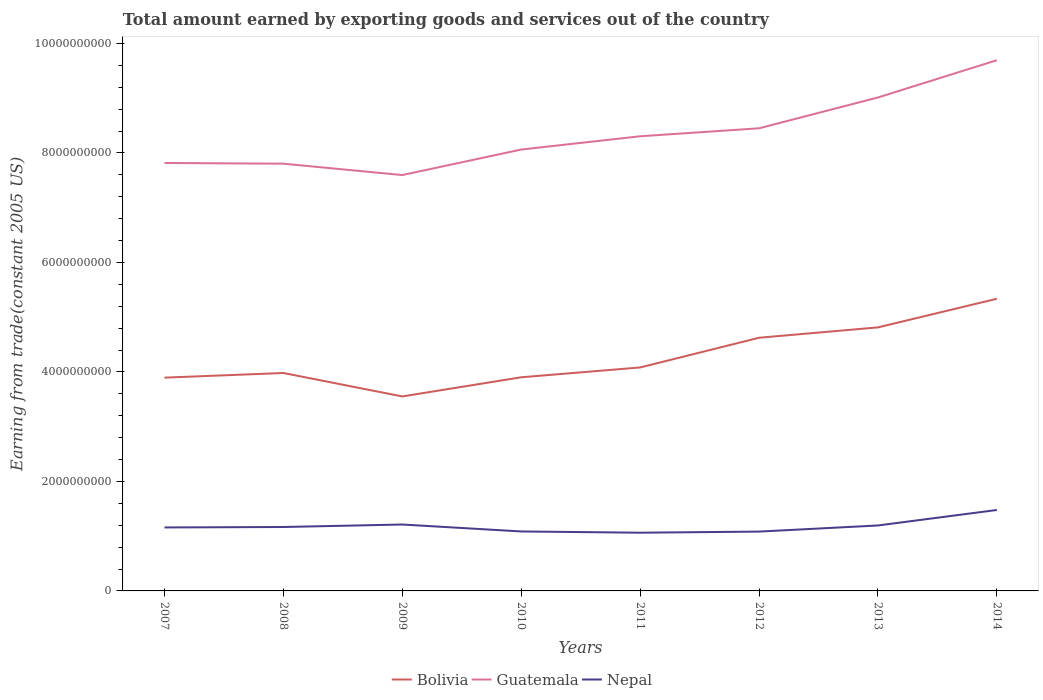How many different coloured lines are there?
Your answer should be very brief. 3. Is the number of lines equal to the number of legend labels?
Offer a very short reply. Yes. Across all years, what is the maximum total amount earned by exporting goods and services in Nepal?
Your answer should be compact. 1.06e+09. What is the total total amount earned by exporting goods and services in Bolivia in the graph?
Your answer should be very brief. -1.44e+09. What is the difference between the highest and the second highest total amount earned by exporting goods and services in Nepal?
Offer a terse response. 4.15e+08. What is the difference between the highest and the lowest total amount earned by exporting goods and services in Bolivia?
Offer a terse response. 3. Is the total amount earned by exporting goods and services in Nepal strictly greater than the total amount earned by exporting goods and services in Guatemala over the years?
Offer a terse response. Yes. Where does the legend appear in the graph?
Offer a terse response. Bottom center. How many legend labels are there?
Offer a terse response. 3. What is the title of the graph?
Make the answer very short. Total amount earned by exporting goods and services out of the country. What is the label or title of the Y-axis?
Give a very brief answer. Earning from trade(constant 2005 US). What is the Earning from trade(constant 2005 US) of Bolivia in 2007?
Your answer should be very brief. 3.90e+09. What is the Earning from trade(constant 2005 US) in Guatemala in 2007?
Give a very brief answer. 7.82e+09. What is the Earning from trade(constant 2005 US) of Nepal in 2007?
Your answer should be very brief. 1.16e+09. What is the Earning from trade(constant 2005 US) of Bolivia in 2008?
Offer a very short reply. 3.98e+09. What is the Earning from trade(constant 2005 US) of Guatemala in 2008?
Your response must be concise. 7.80e+09. What is the Earning from trade(constant 2005 US) in Nepal in 2008?
Offer a terse response. 1.17e+09. What is the Earning from trade(constant 2005 US) of Bolivia in 2009?
Provide a short and direct response. 3.55e+09. What is the Earning from trade(constant 2005 US) in Guatemala in 2009?
Your answer should be very brief. 7.60e+09. What is the Earning from trade(constant 2005 US) in Nepal in 2009?
Make the answer very short. 1.21e+09. What is the Earning from trade(constant 2005 US) in Bolivia in 2010?
Give a very brief answer. 3.90e+09. What is the Earning from trade(constant 2005 US) in Guatemala in 2010?
Ensure brevity in your answer.  8.06e+09. What is the Earning from trade(constant 2005 US) in Nepal in 2010?
Your answer should be compact. 1.09e+09. What is the Earning from trade(constant 2005 US) in Bolivia in 2011?
Provide a succinct answer. 4.08e+09. What is the Earning from trade(constant 2005 US) in Guatemala in 2011?
Make the answer very short. 8.31e+09. What is the Earning from trade(constant 2005 US) in Nepal in 2011?
Your answer should be very brief. 1.06e+09. What is the Earning from trade(constant 2005 US) in Bolivia in 2012?
Your answer should be very brief. 4.62e+09. What is the Earning from trade(constant 2005 US) in Guatemala in 2012?
Provide a short and direct response. 8.45e+09. What is the Earning from trade(constant 2005 US) in Nepal in 2012?
Give a very brief answer. 1.08e+09. What is the Earning from trade(constant 2005 US) in Bolivia in 2013?
Offer a very short reply. 4.81e+09. What is the Earning from trade(constant 2005 US) of Guatemala in 2013?
Ensure brevity in your answer.  9.01e+09. What is the Earning from trade(constant 2005 US) in Nepal in 2013?
Your response must be concise. 1.20e+09. What is the Earning from trade(constant 2005 US) in Bolivia in 2014?
Your answer should be very brief. 5.34e+09. What is the Earning from trade(constant 2005 US) in Guatemala in 2014?
Keep it short and to the point. 9.69e+09. What is the Earning from trade(constant 2005 US) of Nepal in 2014?
Your response must be concise. 1.48e+09. Across all years, what is the maximum Earning from trade(constant 2005 US) in Bolivia?
Ensure brevity in your answer.  5.34e+09. Across all years, what is the maximum Earning from trade(constant 2005 US) of Guatemala?
Your answer should be very brief. 9.69e+09. Across all years, what is the maximum Earning from trade(constant 2005 US) of Nepal?
Keep it short and to the point. 1.48e+09. Across all years, what is the minimum Earning from trade(constant 2005 US) in Bolivia?
Keep it short and to the point. 3.55e+09. Across all years, what is the minimum Earning from trade(constant 2005 US) of Guatemala?
Your response must be concise. 7.60e+09. Across all years, what is the minimum Earning from trade(constant 2005 US) of Nepal?
Your response must be concise. 1.06e+09. What is the total Earning from trade(constant 2005 US) of Bolivia in the graph?
Provide a succinct answer. 3.42e+1. What is the total Earning from trade(constant 2005 US) in Guatemala in the graph?
Make the answer very short. 6.67e+1. What is the total Earning from trade(constant 2005 US) of Nepal in the graph?
Make the answer very short. 9.45e+09. What is the difference between the Earning from trade(constant 2005 US) in Bolivia in 2007 and that in 2008?
Offer a terse response. -8.47e+07. What is the difference between the Earning from trade(constant 2005 US) in Guatemala in 2007 and that in 2008?
Your answer should be compact. 1.27e+07. What is the difference between the Earning from trade(constant 2005 US) in Nepal in 2007 and that in 2008?
Give a very brief answer. -8.43e+06. What is the difference between the Earning from trade(constant 2005 US) of Bolivia in 2007 and that in 2009?
Keep it short and to the point. 3.43e+08. What is the difference between the Earning from trade(constant 2005 US) of Guatemala in 2007 and that in 2009?
Offer a terse response. 2.20e+08. What is the difference between the Earning from trade(constant 2005 US) in Nepal in 2007 and that in 2009?
Ensure brevity in your answer.  -5.36e+07. What is the difference between the Earning from trade(constant 2005 US) of Bolivia in 2007 and that in 2010?
Offer a terse response. -6.59e+06. What is the difference between the Earning from trade(constant 2005 US) of Guatemala in 2007 and that in 2010?
Offer a very short reply. -2.46e+08. What is the difference between the Earning from trade(constant 2005 US) of Nepal in 2007 and that in 2010?
Give a very brief answer. 7.30e+07. What is the difference between the Earning from trade(constant 2005 US) in Bolivia in 2007 and that in 2011?
Offer a terse response. -1.86e+08. What is the difference between the Earning from trade(constant 2005 US) in Guatemala in 2007 and that in 2011?
Keep it short and to the point. -4.88e+08. What is the difference between the Earning from trade(constant 2005 US) of Nepal in 2007 and that in 2011?
Provide a short and direct response. 9.59e+07. What is the difference between the Earning from trade(constant 2005 US) of Bolivia in 2007 and that in 2012?
Your answer should be very brief. -7.29e+08. What is the difference between the Earning from trade(constant 2005 US) in Guatemala in 2007 and that in 2012?
Provide a succinct answer. -6.34e+08. What is the difference between the Earning from trade(constant 2005 US) of Nepal in 2007 and that in 2012?
Your answer should be compact. 7.56e+07. What is the difference between the Earning from trade(constant 2005 US) in Bolivia in 2007 and that in 2013?
Make the answer very short. -9.18e+08. What is the difference between the Earning from trade(constant 2005 US) of Guatemala in 2007 and that in 2013?
Your answer should be compact. -1.20e+09. What is the difference between the Earning from trade(constant 2005 US) in Nepal in 2007 and that in 2013?
Keep it short and to the point. -3.64e+07. What is the difference between the Earning from trade(constant 2005 US) of Bolivia in 2007 and that in 2014?
Offer a very short reply. -1.44e+09. What is the difference between the Earning from trade(constant 2005 US) in Guatemala in 2007 and that in 2014?
Provide a succinct answer. -1.88e+09. What is the difference between the Earning from trade(constant 2005 US) of Nepal in 2007 and that in 2014?
Your response must be concise. -3.19e+08. What is the difference between the Earning from trade(constant 2005 US) in Bolivia in 2008 and that in 2009?
Your response must be concise. 4.28e+08. What is the difference between the Earning from trade(constant 2005 US) in Guatemala in 2008 and that in 2009?
Offer a very short reply. 2.08e+08. What is the difference between the Earning from trade(constant 2005 US) in Nepal in 2008 and that in 2009?
Offer a very short reply. -4.52e+07. What is the difference between the Earning from trade(constant 2005 US) of Bolivia in 2008 and that in 2010?
Ensure brevity in your answer.  7.81e+07. What is the difference between the Earning from trade(constant 2005 US) of Guatemala in 2008 and that in 2010?
Provide a succinct answer. -2.58e+08. What is the difference between the Earning from trade(constant 2005 US) of Nepal in 2008 and that in 2010?
Offer a very short reply. 8.14e+07. What is the difference between the Earning from trade(constant 2005 US) of Bolivia in 2008 and that in 2011?
Your response must be concise. -1.01e+08. What is the difference between the Earning from trade(constant 2005 US) of Guatemala in 2008 and that in 2011?
Make the answer very short. -5.01e+08. What is the difference between the Earning from trade(constant 2005 US) in Nepal in 2008 and that in 2011?
Your answer should be compact. 1.04e+08. What is the difference between the Earning from trade(constant 2005 US) of Bolivia in 2008 and that in 2012?
Ensure brevity in your answer.  -6.44e+08. What is the difference between the Earning from trade(constant 2005 US) in Guatemala in 2008 and that in 2012?
Your response must be concise. -6.46e+08. What is the difference between the Earning from trade(constant 2005 US) of Nepal in 2008 and that in 2012?
Provide a succinct answer. 8.40e+07. What is the difference between the Earning from trade(constant 2005 US) of Bolivia in 2008 and that in 2013?
Ensure brevity in your answer.  -8.33e+08. What is the difference between the Earning from trade(constant 2005 US) of Guatemala in 2008 and that in 2013?
Ensure brevity in your answer.  -1.21e+09. What is the difference between the Earning from trade(constant 2005 US) of Nepal in 2008 and that in 2013?
Provide a short and direct response. -2.80e+07. What is the difference between the Earning from trade(constant 2005 US) of Bolivia in 2008 and that in 2014?
Provide a short and direct response. -1.36e+09. What is the difference between the Earning from trade(constant 2005 US) in Guatemala in 2008 and that in 2014?
Give a very brief answer. -1.89e+09. What is the difference between the Earning from trade(constant 2005 US) in Nepal in 2008 and that in 2014?
Your answer should be very brief. -3.11e+08. What is the difference between the Earning from trade(constant 2005 US) in Bolivia in 2009 and that in 2010?
Keep it short and to the point. -3.50e+08. What is the difference between the Earning from trade(constant 2005 US) in Guatemala in 2009 and that in 2010?
Your response must be concise. -4.66e+08. What is the difference between the Earning from trade(constant 2005 US) in Nepal in 2009 and that in 2010?
Provide a short and direct response. 1.27e+08. What is the difference between the Earning from trade(constant 2005 US) in Bolivia in 2009 and that in 2011?
Ensure brevity in your answer.  -5.29e+08. What is the difference between the Earning from trade(constant 2005 US) in Guatemala in 2009 and that in 2011?
Your response must be concise. -7.08e+08. What is the difference between the Earning from trade(constant 2005 US) in Nepal in 2009 and that in 2011?
Your answer should be compact. 1.50e+08. What is the difference between the Earning from trade(constant 2005 US) in Bolivia in 2009 and that in 2012?
Make the answer very short. -1.07e+09. What is the difference between the Earning from trade(constant 2005 US) of Guatemala in 2009 and that in 2012?
Your response must be concise. -8.54e+08. What is the difference between the Earning from trade(constant 2005 US) in Nepal in 2009 and that in 2012?
Make the answer very short. 1.29e+08. What is the difference between the Earning from trade(constant 2005 US) of Bolivia in 2009 and that in 2013?
Keep it short and to the point. -1.26e+09. What is the difference between the Earning from trade(constant 2005 US) of Guatemala in 2009 and that in 2013?
Your answer should be very brief. -1.42e+09. What is the difference between the Earning from trade(constant 2005 US) in Nepal in 2009 and that in 2013?
Provide a short and direct response. 1.72e+07. What is the difference between the Earning from trade(constant 2005 US) in Bolivia in 2009 and that in 2014?
Your answer should be very brief. -1.78e+09. What is the difference between the Earning from trade(constant 2005 US) of Guatemala in 2009 and that in 2014?
Your answer should be very brief. -2.10e+09. What is the difference between the Earning from trade(constant 2005 US) of Nepal in 2009 and that in 2014?
Your response must be concise. -2.66e+08. What is the difference between the Earning from trade(constant 2005 US) of Bolivia in 2010 and that in 2011?
Your response must be concise. -1.79e+08. What is the difference between the Earning from trade(constant 2005 US) of Guatemala in 2010 and that in 2011?
Make the answer very short. -2.43e+08. What is the difference between the Earning from trade(constant 2005 US) of Nepal in 2010 and that in 2011?
Offer a terse response. 2.30e+07. What is the difference between the Earning from trade(constant 2005 US) of Bolivia in 2010 and that in 2012?
Your response must be concise. -7.22e+08. What is the difference between the Earning from trade(constant 2005 US) of Guatemala in 2010 and that in 2012?
Your answer should be compact. -3.88e+08. What is the difference between the Earning from trade(constant 2005 US) in Nepal in 2010 and that in 2012?
Offer a very short reply. 2.59e+06. What is the difference between the Earning from trade(constant 2005 US) in Bolivia in 2010 and that in 2013?
Ensure brevity in your answer.  -9.11e+08. What is the difference between the Earning from trade(constant 2005 US) in Guatemala in 2010 and that in 2013?
Keep it short and to the point. -9.51e+08. What is the difference between the Earning from trade(constant 2005 US) in Nepal in 2010 and that in 2013?
Offer a terse response. -1.09e+08. What is the difference between the Earning from trade(constant 2005 US) of Bolivia in 2010 and that in 2014?
Ensure brevity in your answer.  -1.43e+09. What is the difference between the Earning from trade(constant 2005 US) in Guatemala in 2010 and that in 2014?
Keep it short and to the point. -1.63e+09. What is the difference between the Earning from trade(constant 2005 US) of Nepal in 2010 and that in 2014?
Your answer should be compact. -3.92e+08. What is the difference between the Earning from trade(constant 2005 US) in Bolivia in 2011 and that in 2012?
Offer a terse response. -5.43e+08. What is the difference between the Earning from trade(constant 2005 US) in Guatemala in 2011 and that in 2012?
Offer a terse response. -1.46e+08. What is the difference between the Earning from trade(constant 2005 US) of Nepal in 2011 and that in 2012?
Your response must be concise. -2.04e+07. What is the difference between the Earning from trade(constant 2005 US) in Bolivia in 2011 and that in 2013?
Your answer should be compact. -7.32e+08. What is the difference between the Earning from trade(constant 2005 US) in Guatemala in 2011 and that in 2013?
Provide a succinct answer. -7.09e+08. What is the difference between the Earning from trade(constant 2005 US) in Nepal in 2011 and that in 2013?
Ensure brevity in your answer.  -1.32e+08. What is the difference between the Earning from trade(constant 2005 US) of Bolivia in 2011 and that in 2014?
Give a very brief answer. -1.26e+09. What is the difference between the Earning from trade(constant 2005 US) in Guatemala in 2011 and that in 2014?
Provide a short and direct response. -1.39e+09. What is the difference between the Earning from trade(constant 2005 US) of Nepal in 2011 and that in 2014?
Provide a short and direct response. -4.15e+08. What is the difference between the Earning from trade(constant 2005 US) of Bolivia in 2012 and that in 2013?
Make the answer very short. -1.89e+08. What is the difference between the Earning from trade(constant 2005 US) in Guatemala in 2012 and that in 2013?
Your answer should be compact. -5.63e+08. What is the difference between the Earning from trade(constant 2005 US) of Nepal in 2012 and that in 2013?
Your answer should be very brief. -1.12e+08. What is the difference between the Earning from trade(constant 2005 US) of Bolivia in 2012 and that in 2014?
Ensure brevity in your answer.  -7.12e+08. What is the difference between the Earning from trade(constant 2005 US) in Guatemala in 2012 and that in 2014?
Provide a succinct answer. -1.24e+09. What is the difference between the Earning from trade(constant 2005 US) of Nepal in 2012 and that in 2014?
Your answer should be compact. -3.95e+08. What is the difference between the Earning from trade(constant 2005 US) of Bolivia in 2013 and that in 2014?
Offer a very short reply. -5.23e+08. What is the difference between the Earning from trade(constant 2005 US) of Guatemala in 2013 and that in 2014?
Ensure brevity in your answer.  -6.81e+08. What is the difference between the Earning from trade(constant 2005 US) of Nepal in 2013 and that in 2014?
Provide a short and direct response. -2.83e+08. What is the difference between the Earning from trade(constant 2005 US) in Bolivia in 2007 and the Earning from trade(constant 2005 US) in Guatemala in 2008?
Your answer should be compact. -3.91e+09. What is the difference between the Earning from trade(constant 2005 US) of Bolivia in 2007 and the Earning from trade(constant 2005 US) of Nepal in 2008?
Your answer should be very brief. 2.73e+09. What is the difference between the Earning from trade(constant 2005 US) in Guatemala in 2007 and the Earning from trade(constant 2005 US) in Nepal in 2008?
Provide a succinct answer. 6.65e+09. What is the difference between the Earning from trade(constant 2005 US) of Bolivia in 2007 and the Earning from trade(constant 2005 US) of Guatemala in 2009?
Your answer should be compact. -3.70e+09. What is the difference between the Earning from trade(constant 2005 US) of Bolivia in 2007 and the Earning from trade(constant 2005 US) of Nepal in 2009?
Keep it short and to the point. 2.68e+09. What is the difference between the Earning from trade(constant 2005 US) in Guatemala in 2007 and the Earning from trade(constant 2005 US) in Nepal in 2009?
Your response must be concise. 6.60e+09. What is the difference between the Earning from trade(constant 2005 US) in Bolivia in 2007 and the Earning from trade(constant 2005 US) in Guatemala in 2010?
Ensure brevity in your answer.  -4.17e+09. What is the difference between the Earning from trade(constant 2005 US) of Bolivia in 2007 and the Earning from trade(constant 2005 US) of Nepal in 2010?
Give a very brief answer. 2.81e+09. What is the difference between the Earning from trade(constant 2005 US) of Guatemala in 2007 and the Earning from trade(constant 2005 US) of Nepal in 2010?
Provide a short and direct response. 6.73e+09. What is the difference between the Earning from trade(constant 2005 US) of Bolivia in 2007 and the Earning from trade(constant 2005 US) of Guatemala in 2011?
Offer a very short reply. -4.41e+09. What is the difference between the Earning from trade(constant 2005 US) in Bolivia in 2007 and the Earning from trade(constant 2005 US) in Nepal in 2011?
Offer a very short reply. 2.83e+09. What is the difference between the Earning from trade(constant 2005 US) of Guatemala in 2007 and the Earning from trade(constant 2005 US) of Nepal in 2011?
Your response must be concise. 6.75e+09. What is the difference between the Earning from trade(constant 2005 US) in Bolivia in 2007 and the Earning from trade(constant 2005 US) in Guatemala in 2012?
Offer a terse response. -4.55e+09. What is the difference between the Earning from trade(constant 2005 US) of Bolivia in 2007 and the Earning from trade(constant 2005 US) of Nepal in 2012?
Ensure brevity in your answer.  2.81e+09. What is the difference between the Earning from trade(constant 2005 US) in Guatemala in 2007 and the Earning from trade(constant 2005 US) in Nepal in 2012?
Give a very brief answer. 6.73e+09. What is the difference between the Earning from trade(constant 2005 US) in Bolivia in 2007 and the Earning from trade(constant 2005 US) in Guatemala in 2013?
Keep it short and to the point. -5.12e+09. What is the difference between the Earning from trade(constant 2005 US) of Bolivia in 2007 and the Earning from trade(constant 2005 US) of Nepal in 2013?
Your answer should be compact. 2.70e+09. What is the difference between the Earning from trade(constant 2005 US) in Guatemala in 2007 and the Earning from trade(constant 2005 US) in Nepal in 2013?
Make the answer very short. 6.62e+09. What is the difference between the Earning from trade(constant 2005 US) in Bolivia in 2007 and the Earning from trade(constant 2005 US) in Guatemala in 2014?
Offer a very short reply. -5.80e+09. What is the difference between the Earning from trade(constant 2005 US) of Bolivia in 2007 and the Earning from trade(constant 2005 US) of Nepal in 2014?
Offer a very short reply. 2.42e+09. What is the difference between the Earning from trade(constant 2005 US) in Guatemala in 2007 and the Earning from trade(constant 2005 US) in Nepal in 2014?
Offer a very short reply. 6.34e+09. What is the difference between the Earning from trade(constant 2005 US) in Bolivia in 2008 and the Earning from trade(constant 2005 US) in Guatemala in 2009?
Offer a very short reply. -3.62e+09. What is the difference between the Earning from trade(constant 2005 US) in Bolivia in 2008 and the Earning from trade(constant 2005 US) in Nepal in 2009?
Keep it short and to the point. 2.77e+09. What is the difference between the Earning from trade(constant 2005 US) in Guatemala in 2008 and the Earning from trade(constant 2005 US) in Nepal in 2009?
Offer a terse response. 6.59e+09. What is the difference between the Earning from trade(constant 2005 US) in Bolivia in 2008 and the Earning from trade(constant 2005 US) in Guatemala in 2010?
Offer a very short reply. -4.08e+09. What is the difference between the Earning from trade(constant 2005 US) of Bolivia in 2008 and the Earning from trade(constant 2005 US) of Nepal in 2010?
Your answer should be very brief. 2.89e+09. What is the difference between the Earning from trade(constant 2005 US) in Guatemala in 2008 and the Earning from trade(constant 2005 US) in Nepal in 2010?
Keep it short and to the point. 6.72e+09. What is the difference between the Earning from trade(constant 2005 US) of Bolivia in 2008 and the Earning from trade(constant 2005 US) of Guatemala in 2011?
Keep it short and to the point. -4.32e+09. What is the difference between the Earning from trade(constant 2005 US) in Bolivia in 2008 and the Earning from trade(constant 2005 US) in Nepal in 2011?
Offer a very short reply. 2.92e+09. What is the difference between the Earning from trade(constant 2005 US) in Guatemala in 2008 and the Earning from trade(constant 2005 US) in Nepal in 2011?
Provide a short and direct response. 6.74e+09. What is the difference between the Earning from trade(constant 2005 US) in Bolivia in 2008 and the Earning from trade(constant 2005 US) in Guatemala in 2012?
Offer a very short reply. -4.47e+09. What is the difference between the Earning from trade(constant 2005 US) of Bolivia in 2008 and the Earning from trade(constant 2005 US) of Nepal in 2012?
Offer a very short reply. 2.90e+09. What is the difference between the Earning from trade(constant 2005 US) in Guatemala in 2008 and the Earning from trade(constant 2005 US) in Nepal in 2012?
Your answer should be compact. 6.72e+09. What is the difference between the Earning from trade(constant 2005 US) of Bolivia in 2008 and the Earning from trade(constant 2005 US) of Guatemala in 2013?
Ensure brevity in your answer.  -5.03e+09. What is the difference between the Earning from trade(constant 2005 US) of Bolivia in 2008 and the Earning from trade(constant 2005 US) of Nepal in 2013?
Offer a very short reply. 2.79e+09. What is the difference between the Earning from trade(constant 2005 US) of Guatemala in 2008 and the Earning from trade(constant 2005 US) of Nepal in 2013?
Your response must be concise. 6.61e+09. What is the difference between the Earning from trade(constant 2005 US) of Bolivia in 2008 and the Earning from trade(constant 2005 US) of Guatemala in 2014?
Offer a very short reply. -5.71e+09. What is the difference between the Earning from trade(constant 2005 US) of Bolivia in 2008 and the Earning from trade(constant 2005 US) of Nepal in 2014?
Your answer should be compact. 2.50e+09. What is the difference between the Earning from trade(constant 2005 US) of Guatemala in 2008 and the Earning from trade(constant 2005 US) of Nepal in 2014?
Provide a short and direct response. 6.33e+09. What is the difference between the Earning from trade(constant 2005 US) of Bolivia in 2009 and the Earning from trade(constant 2005 US) of Guatemala in 2010?
Make the answer very short. -4.51e+09. What is the difference between the Earning from trade(constant 2005 US) of Bolivia in 2009 and the Earning from trade(constant 2005 US) of Nepal in 2010?
Offer a very short reply. 2.47e+09. What is the difference between the Earning from trade(constant 2005 US) in Guatemala in 2009 and the Earning from trade(constant 2005 US) in Nepal in 2010?
Offer a terse response. 6.51e+09. What is the difference between the Earning from trade(constant 2005 US) in Bolivia in 2009 and the Earning from trade(constant 2005 US) in Guatemala in 2011?
Your response must be concise. -4.75e+09. What is the difference between the Earning from trade(constant 2005 US) of Bolivia in 2009 and the Earning from trade(constant 2005 US) of Nepal in 2011?
Ensure brevity in your answer.  2.49e+09. What is the difference between the Earning from trade(constant 2005 US) of Guatemala in 2009 and the Earning from trade(constant 2005 US) of Nepal in 2011?
Offer a very short reply. 6.53e+09. What is the difference between the Earning from trade(constant 2005 US) of Bolivia in 2009 and the Earning from trade(constant 2005 US) of Guatemala in 2012?
Your answer should be very brief. -4.90e+09. What is the difference between the Earning from trade(constant 2005 US) in Bolivia in 2009 and the Earning from trade(constant 2005 US) in Nepal in 2012?
Your answer should be very brief. 2.47e+09. What is the difference between the Earning from trade(constant 2005 US) in Guatemala in 2009 and the Earning from trade(constant 2005 US) in Nepal in 2012?
Make the answer very short. 6.51e+09. What is the difference between the Earning from trade(constant 2005 US) in Bolivia in 2009 and the Earning from trade(constant 2005 US) in Guatemala in 2013?
Your answer should be compact. -5.46e+09. What is the difference between the Earning from trade(constant 2005 US) of Bolivia in 2009 and the Earning from trade(constant 2005 US) of Nepal in 2013?
Provide a succinct answer. 2.36e+09. What is the difference between the Earning from trade(constant 2005 US) of Guatemala in 2009 and the Earning from trade(constant 2005 US) of Nepal in 2013?
Ensure brevity in your answer.  6.40e+09. What is the difference between the Earning from trade(constant 2005 US) in Bolivia in 2009 and the Earning from trade(constant 2005 US) in Guatemala in 2014?
Keep it short and to the point. -6.14e+09. What is the difference between the Earning from trade(constant 2005 US) in Bolivia in 2009 and the Earning from trade(constant 2005 US) in Nepal in 2014?
Your response must be concise. 2.07e+09. What is the difference between the Earning from trade(constant 2005 US) of Guatemala in 2009 and the Earning from trade(constant 2005 US) of Nepal in 2014?
Offer a terse response. 6.12e+09. What is the difference between the Earning from trade(constant 2005 US) in Bolivia in 2010 and the Earning from trade(constant 2005 US) in Guatemala in 2011?
Your answer should be very brief. -4.40e+09. What is the difference between the Earning from trade(constant 2005 US) in Bolivia in 2010 and the Earning from trade(constant 2005 US) in Nepal in 2011?
Offer a terse response. 2.84e+09. What is the difference between the Earning from trade(constant 2005 US) of Guatemala in 2010 and the Earning from trade(constant 2005 US) of Nepal in 2011?
Keep it short and to the point. 7.00e+09. What is the difference between the Earning from trade(constant 2005 US) in Bolivia in 2010 and the Earning from trade(constant 2005 US) in Guatemala in 2012?
Offer a terse response. -4.55e+09. What is the difference between the Earning from trade(constant 2005 US) in Bolivia in 2010 and the Earning from trade(constant 2005 US) in Nepal in 2012?
Your answer should be compact. 2.82e+09. What is the difference between the Earning from trade(constant 2005 US) in Guatemala in 2010 and the Earning from trade(constant 2005 US) in Nepal in 2012?
Give a very brief answer. 6.98e+09. What is the difference between the Earning from trade(constant 2005 US) in Bolivia in 2010 and the Earning from trade(constant 2005 US) in Guatemala in 2013?
Ensure brevity in your answer.  -5.11e+09. What is the difference between the Earning from trade(constant 2005 US) of Bolivia in 2010 and the Earning from trade(constant 2005 US) of Nepal in 2013?
Offer a terse response. 2.71e+09. What is the difference between the Earning from trade(constant 2005 US) of Guatemala in 2010 and the Earning from trade(constant 2005 US) of Nepal in 2013?
Offer a terse response. 6.87e+09. What is the difference between the Earning from trade(constant 2005 US) of Bolivia in 2010 and the Earning from trade(constant 2005 US) of Guatemala in 2014?
Your response must be concise. -5.79e+09. What is the difference between the Earning from trade(constant 2005 US) of Bolivia in 2010 and the Earning from trade(constant 2005 US) of Nepal in 2014?
Provide a short and direct response. 2.42e+09. What is the difference between the Earning from trade(constant 2005 US) of Guatemala in 2010 and the Earning from trade(constant 2005 US) of Nepal in 2014?
Offer a terse response. 6.58e+09. What is the difference between the Earning from trade(constant 2005 US) of Bolivia in 2011 and the Earning from trade(constant 2005 US) of Guatemala in 2012?
Your answer should be compact. -4.37e+09. What is the difference between the Earning from trade(constant 2005 US) of Bolivia in 2011 and the Earning from trade(constant 2005 US) of Nepal in 2012?
Your answer should be compact. 3.00e+09. What is the difference between the Earning from trade(constant 2005 US) of Guatemala in 2011 and the Earning from trade(constant 2005 US) of Nepal in 2012?
Your answer should be very brief. 7.22e+09. What is the difference between the Earning from trade(constant 2005 US) in Bolivia in 2011 and the Earning from trade(constant 2005 US) in Guatemala in 2013?
Keep it short and to the point. -4.93e+09. What is the difference between the Earning from trade(constant 2005 US) in Bolivia in 2011 and the Earning from trade(constant 2005 US) in Nepal in 2013?
Your answer should be very brief. 2.89e+09. What is the difference between the Earning from trade(constant 2005 US) of Guatemala in 2011 and the Earning from trade(constant 2005 US) of Nepal in 2013?
Give a very brief answer. 7.11e+09. What is the difference between the Earning from trade(constant 2005 US) in Bolivia in 2011 and the Earning from trade(constant 2005 US) in Guatemala in 2014?
Offer a very short reply. -5.61e+09. What is the difference between the Earning from trade(constant 2005 US) in Bolivia in 2011 and the Earning from trade(constant 2005 US) in Nepal in 2014?
Give a very brief answer. 2.60e+09. What is the difference between the Earning from trade(constant 2005 US) of Guatemala in 2011 and the Earning from trade(constant 2005 US) of Nepal in 2014?
Your response must be concise. 6.83e+09. What is the difference between the Earning from trade(constant 2005 US) of Bolivia in 2012 and the Earning from trade(constant 2005 US) of Guatemala in 2013?
Offer a terse response. -4.39e+09. What is the difference between the Earning from trade(constant 2005 US) of Bolivia in 2012 and the Earning from trade(constant 2005 US) of Nepal in 2013?
Provide a succinct answer. 3.43e+09. What is the difference between the Earning from trade(constant 2005 US) in Guatemala in 2012 and the Earning from trade(constant 2005 US) in Nepal in 2013?
Your answer should be compact. 7.26e+09. What is the difference between the Earning from trade(constant 2005 US) in Bolivia in 2012 and the Earning from trade(constant 2005 US) in Guatemala in 2014?
Keep it short and to the point. -5.07e+09. What is the difference between the Earning from trade(constant 2005 US) in Bolivia in 2012 and the Earning from trade(constant 2005 US) in Nepal in 2014?
Provide a succinct answer. 3.15e+09. What is the difference between the Earning from trade(constant 2005 US) in Guatemala in 2012 and the Earning from trade(constant 2005 US) in Nepal in 2014?
Your response must be concise. 6.97e+09. What is the difference between the Earning from trade(constant 2005 US) in Bolivia in 2013 and the Earning from trade(constant 2005 US) in Guatemala in 2014?
Ensure brevity in your answer.  -4.88e+09. What is the difference between the Earning from trade(constant 2005 US) of Bolivia in 2013 and the Earning from trade(constant 2005 US) of Nepal in 2014?
Make the answer very short. 3.34e+09. What is the difference between the Earning from trade(constant 2005 US) in Guatemala in 2013 and the Earning from trade(constant 2005 US) in Nepal in 2014?
Provide a succinct answer. 7.54e+09. What is the average Earning from trade(constant 2005 US) in Bolivia per year?
Ensure brevity in your answer.  4.27e+09. What is the average Earning from trade(constant 2005 US) of Guatemala per year?
Your response must be concise. 8.34e+09. What is the average Earning from trade(constant 2005 US) of Nepal per year?
Your answer should be very brief. 1.18e+09. In the year 2007, what is the difference between the Earning from trade(constant 2005 US) of Bolivia and Earning from trade(constant 2005 US) of Guatemala?
Provide a short and direct response. -3.92e+09. In the year 2007, what is the difference between the Earning from trade(constant 2005 US) of Bolivia and Earning from trade(constant 2005 US) of Nepal?
Offer a very short reply. 2.74e+09. In the year 2007, what is the difference between the Earning from trade(constant 2005 US) in Guatemala and Earning from trade(constant 2005 US) in Nepal?
Offer a very short reply. 6.66e+09. In the year 2008, what is the difference between the Earning from trade(constant 2005 US) in Bolivia and Earning from trade(constant 2005 US) in Guatemala?
Provide a succinct answer. -3.82e+09. In the year 2008, what is the difference between the Earning from trade(constant 2005 US) of Bolivia and Earning from trade(constant 2005 US) of Nepal?
Give a very brief answer. 2.81e+09. In the year 2008, what is the difference between the Earning from trade(constant 2005 US) in Guatemala and Earning from trade(constant 2005 US) in Nepal?
Your response must be concise. 6.64e+09. In the year 2009, what is the difference between the Earning from trade(constant 2005 US) of Bolivia and Earning from trade(constant 2005 US) of Guatemala?
Provide a succinct answer. -4.04e+09. In the year 2009, what is the difference between the Earning from trade(constant 2005 US) of Bolivia and Earning from trade(constant 2005 US) of Nepal?
Your answer should be very brief. 2.34e+09. In the year 2009, what is the difference between the Earning from trade(constant 2005 US) in Guatemala and Earning from trade(constant 2005 US) in Nepal?
Provide a short and direct response. 6.38e+09. In the year 2010, what is the difference between the Earning from trade(constant 2005 US) of Bolivia and Earning from trade(constant 2005 US) of Guatemala?
Your answer should be very brief. -4.16e+09. In the year 2010, what is the difference between the Earning from trade(constant 2005 US) in Bolivia and Earning from trade(constant 2005 US) in Nepal?
Keep it short and to the point. 2.82e+09. In the year 2010, what is the difference between the Earning from trade(constant 2005 US) in Guatemala and Earning from trade(constant 2005 US) in Nepal?
Make the answer very short. 6.98e+09. In the year 2011, what is the difference between the Earning from trade(constant 2005 US) of Bolivia and Earning from trade(constant 2005 US) of Guatemala?
Make the answer very short. -4.22e+09. In the year 2011, what is the difference between the Earning from trade(constant 2005 US) in Bolivia and Earning from trade(constant 2005 US) in Nepal?
Your answer should be compact. 3.02e+09. In the year 2011, what is the difference between the Earning from trade(constant 2005 US) in Guatemala and Earning from trade(constant 2005 US) in Nepal?
Provide a succinct answer. 7.24e+09. In the year 2012, what is the difference between the Earning from trade(constant 2005 US) of Bolivia and Earning from trade(constant 2005 US) of Guatemala?
Make the answer very short. -3.83e+09. In the year 2012, what is the difference between the Earning from trade(constant 2005 US) of Bolivia and Earning from trade(constant 2005 US) of Nepal?
Make the answer very short. 3.54e+09. In the year 2012, what is the difference between the Earning from trade(constant 2005 US) of Guatemala and Earning from trade(constant 2005 US) of Nepal?
Keep it short and to the point. 7.37e+09. In the year 2013, what is the difference between the Earning from trade(constant 2005 US) in Bolivia and Earning from trade(constant 2005 US) in Guatemala?
Ensure brevity in your answer.  -4.20e+09. In the year 2013, what is the difference between the Earning from trade(constant 2005 US) in Bolivia and Earning from trade(constant 2005 US) in Nepal?
Make the answer very short. 3.62e+09. In the year 2013, what is the difference between the Earning from trade(constant 2005 US) in Guatemala and Earning from trade(constant 2005 US) in Nepal?
Offer a terse response. 7.82e+09. In the year 2014, what is the difference between the Earning from trade(constant 2005 US) in Bolivia and Earning from trade(constant 2005 US) in Guatemala?
Provide a succinct answer. -4.36e+09. In the year 2014, what is the difference between the Earning from trade(constant 2005 US) of Bolivia and Earning from trade(constant 2005 US) of Nepal?
Make the answer very short. 3.86e+09. In the year 2014, what is the difference between the Earning from trade(constant 2005 US) in Guatemala and Earning from trade(constant 2005 US) in Nepal?
Provide a short and direct response. 8.22e+09. What is the ratio of the Earning from trade(constant 2005 US) in Bolivia in 2007 to that in 2008?
Your answer should be very brief. 0.98. What is the ratio of the Earning from trade(constant 2005 US) in Guatemala in 2007 to that in 2008?
Offer a very short reply. 1. What is the ratio of the Earning from trade(constant 2005 US) in Nepal in 2007 to that in 2008?
Make the answer very short. 0.99. What is the ratio of the Earning from trade(constant 2005 US) of Bolivia in 2007 to that in 2009?
Your answer should be very brief. 1.1. What is the ratio of the Earning from trade(constant 2005 US) in Nepal in 2007 to that in 2009?
Your response must be concise. 0.96. What is the ratio of the Earning from trade(constant 2005 US) in Guatemala in 2007 to that in 2010?
Your response must be concise. 0.97. What is the ratio of the Earning from trade(constant 2005 US) of Nepal in 2007 to that in 2010?
Give a very brief answer. 1.07. What is the ratio of the Earning from trade(constant 2005 US) in Bolivia in 2007 to that in 2011?
Keep it short and to the point. 0.95. What is the ratio of the Earning from trade(constant 2005 US) of Nepal in 2007 to that in 2011?
Make the answer very short. 1.09. What is the ratio of the Earning from trade(constant 2005 US) in Bolivia in 2007 to that in 2012?
Make the answer very short. 0.84. What is the ratio of the Earning from trade(constant 2005 US) of Guatemala in 2007 to that in 2012?
Provide a succinct answer. 0.93. What is the ratio of the Earning from trade(constant 2005 US) of Nepal in 2007 to that in 2012?
Give a very brief answer. 1.07. What is the ratio of the Earning from trade(constant 2005 US) in Bolivia in 2007 to that in 2013?
Your response must be concise. 0.81. What is the ratio of the Earning from trade(constant 2005 US) of Guatemala in 2007 to that in 2013?
Provide a succinct answer. 0.87. What is the ratio of the Earning from trade(constant 2005 US) of Nepal in 2007 to that in 2013?
Make the answer very short. 0.97. What is the ratio of the Earning from trade(constant 2005 US) in Bolivia in 2007 to that in 2014?
Provide a succinct answer. 0.73. What is the ratio of the Earning from trade(constant 2005 US) of Guatemala in 2007 to that in 2014?
Keep it short and to the point. 0.81. What is the ratio of the Earning from trade(constant 2005 US) in Nepal in 2007 to that in 2014?
Offer a terse response. 0.78. What is the ratio of the Earning from trade(constant 2005 US) of Bolivia in 2008 to that in 2009?
Your response must be concise. 1.12. What is the ratio of the Earning from trade(constant 2005 US) in Guatemala in 2008 to that in 2009?
Give a very brief answer. 1.03. What is the ratio of the Earning from trade(constant 2005 US) of Nepal in 2008 to that in 2009?
Offer a very short reply. 0.96. What is the ratio of the Earning from trade(constant 2005 US) of Bolivia in 2008 to that in 2010?
Ensure brevity in your answer.  1.02. What is the ratio of the Earning from trade(constant 2005 US) of Nepal in 2008 to that in 2010?
Ensure brevity in your answer.  1.07. What is the ratio of the Earning from trade(constant 2005 US) of Bolivia in 2008 to that in 2011?
Your answer should be very brief. 0.98. What is the ratio of the Earning from trade(constant 2005 US) of Guatemala in 2008 to that in 2011?
Give a very brief answer. 0.94. What is the ratio of the Earning from trade(constant 2005 US) of Nepal in 2008 to that in 2011?
Your answer should be compact. 1.1. What is the ratio of the Earning from trade(constant 2005 US) of Bolivia in 2008 to that in 2012?
Offer a terse response. 0.86. What is the ratio of the Earning from trade(constant 2005 US) of Guatemala in 2008 to that in 2012?
Ensure brevity in your answer.  0.92. What is the ratio of the Earning from trade(constant 2005 US) of Nepal in 2008 to that in 2012?
Offer a very short reply. 1.08. What is the ratio of the Earning from trade(constant 2005 US) in Bolivia in 2008 to that in 2013?
Your response must be concise. 0.83. What is the ratio of the Earning from trade(constant 2005 US) in Guatemala in 2008 to that in 2013?
Offer a terse response. 0.87. What is the ratio of the Earning from trade(constant 2005 US) in Nepal in 2008 to that in 2013?
Ensure brevity in your answer.  0.98. What is the ratio of the Earning from trade(constant 2005 US) of Bolivia in 2008 to that in 2014?
Give a very brief answer. 0.75. What is the ratio of the Earning from trade(constant 2005 US) of Guatemala in 2008 to that in 2014?
Ensure brevity in your answer.  0.81. What is the ratio of the Earning from trade(constant 2005 US) of Nepal in 2008 to that in 2014?
Your response must be concise. 0.79. What is the ratio of the Earning from trade(constant 2005 US) of Bolivia in 2009 to that in 2010?
Give a very brief answer. 0.91. What is the ratio of the Earning from trade(constant 2005 US) in Guatemala in 2009 to that in 2010?
Ensure brevity in your answer.  0.94. What is the ratio of the Earning from trade(constant 2005 US) of Nepal in 2009 to that in 2010?
Make the answer very short. 1.12. What is the ratio of the Earning from trade(constant 2005 US) in Bolivia in 2009 to that in 2011?
Your answer should be very brief. 0.87. What is the ratio of the Earning from trade(constant 2005 US) in Guatemala in 2009 to that in 2011?
Ensure brevity in your answer.  0.91. What is the ratio of the Earning from trade(constant 2005 US) of Nepal in 2009 to that in 2011?
Keep it short and to the point. 1.14. What is the ratio of the Earning from trade(constant 2005 US) in Bolivia in 2009 to that in 2012?
Your answer should be very brief. 0.77. What is the ratio of the Earning from trade(constant 2005 US) in Guatemala in 2009 to that in 2012?
Your answer should be compact. 0.9. What is the ratio of the Earning from trade(constant 2005 US) in Nepal in 2009 to that in 2012?
Your answer should be compact. 1.12. What is the ratio of the Earning from trade(constant 2005 US) in Bolivia in 2009 to that in 2013?
Provide a short and direct response. 0.74. What is the ratio of the Earning from trade(constant 2005 US) in Guatemala in 2009 to that in 2013?
Your answer should be compact. 0.84. What is the ratio of the Earning from trade(constant 2005 US) of Nepal in 2009 to that in 2013?
Offer a terse response. 1.01. What is the ratio of the Earning from trade(constant 2005 US) in Bolivia in 2009 to that in 2014?
Offer a terse response. 0.67. What is the ratio of the Earning from trade(constant 2005 US) in Guatemala in 2009 to that in 2014?
Provide a short and direct response. 0.78. What is the ratio of the Earning from trade(constant 2005 US) in Nepal in 2009 to that in 2014?
Give a very brief answer. 0.82. What is the ratio of the Earning from trade(constant 2005 US) of Bolivia in 2010 to that in 2011?
Give a very brief answer. 0.96. What is the ratio of the Earning from trade(constant 2005 US) of Guatemala in 2010 to that in 2011?
Offer a very short reply. 0.97. What is the ratio of the Earning from trade(constant 2005 US) of Nepal in 2010 to that in 2011?
Provide a short and direct response. 1.02. What is the ratio of the Earning from trade(constant 2005 US) in Bolivia in 2010 to that in 2012?
Keep it short and to the point. 0.84. What is the ratio of the Earning from trade(constant 2005 US) of Guatemala in 2010 to that in 2012?
Your answer should be compact. 0.95. What is the ratio of the Earning from trade(constant 2005 US) in Bolivia in 2010 to that in 2013?
Give a very brief answer. 0.81. What is the ratio of the Earning from trade(constant 2005 US) in Guatemala in 2010 to that in 2013?
Your answer should be very brief. 0.89. What is the ratio of the Earning from trade(constant 2005 US) in Nepal in 2010 to that in 2013?
Your response must be concise. 0.91. What is the ratio of the Earning from trade(constant 2005 US) of Bolivia in 2010 to that in 2014?
Offer a very short reply. 0.73. What is the ratio of the Earning from trade(constant 2005 US) of Guatemala in 2010 to that in 2014?
Give a very brief answer. 0.83. What is the ratio of the Earning from trade(constant 2005 US) in Nepal in 2010 to that in 2014?
Offer a very short reply. 0.73. What is the ratio of the Earning from trade(constant 2005 US) of Bolivia in 2011 to that in 2012?
Provide a short and direct response. 0.88. What is the ratio of the Earning from trade(constant 2005 US) in Guatemala in 2011 to that in 2012?
Your answer should be compact. 0.98. What is the ratio of the Earning from trade(constant 2005 US) of Nepal in 2011 to that in 2012?
Provide a short and direct response. 0.98. What is the ratio of the Earning from trade(constant 2005 US) of Bolivia in 2011 to that in 2013?
Your answer should be compact. 0.85. What is the ratio of the Earning from trade(constant 2005 US) of Guatemala in 2011 to that in 2013?
Provide a succinct answer. 0.92. What is the ratio of the Earning from trade(constant 2005 US) of Nepal in 2011 to that in 2013?
Your answer should be compact. 0.89. What is the ratio of the Earning from trade(constant 2005 US) in Bolivia in 2011 to that in 2014?
Your answer should be very brief. 0.76. What is the ratio of the Earning from trade(constant 2005 US) of Guatemala in 2011 to that in 2014?
Provide a succinct answer. 0.86. What is the ratio of the Earning from trade(constant 2005 US) in Nepal in 2011 to that in 2014?
Your answer should be compact. 0.72. What is the ratio of the Earning from trade(constant 2005 US) in Bolivia in 2012 to that in 2013?
Offer a very short reply. 0.96. What is the ratio of the Earning from trade(constant 2005 US) in Nepal in 2012 to that in 2013?
Your answer should be very brief. 0.91. What is the ratio of the Earning from trade(constant 2005 US) of Bolivia in 2012 to that in 2014?
Keep it short and to the point. 0.87. What is the ratio of the Earning from trade(constant 2005 US) of Guatemala in 2012 to that in 2014?
Your answer should be very brief. 0.87. What is the ratio of the Earning from trade(constant 2005 US) of Nepal in 2012 to that in 2014?
Your answer should be compact. 0.73. What is the ratio of the Earning from trade(constant 2005 US) in Bolivia in 2013 to that in 2014?
Give a very brief answer. 0.9. What is the ratio of the Earning from trade(constant 2005 US) of Guatemala in 2013 to that in 2014?
Offer a terse response. 0.93. What is the ratio of the Earning from trade(constant 2005 US) in Nepal in 2013 to that in 2014?
Offer a terse response. 0.81. What is the difference between the highest and the second highest Earning from trade(constant 2005 US) in Bolivia?
Your answer should be very brief. 5.23e+08. What is the difference between the highest and the second highest Earning from trade(constant 2005 US) of Guatemala?
Keep it short and to the point. 6.81e+08. What is the difference between the highest and the second highest Earning from trade(constant 2005 US) of Nepal?
Your answer should be compact. 2.66e+08. What is the difference between the highest and the lowest Earning from trade(constant 2005 US) in Bolivia?
Make the answer very short. 1.78e+09. What is the difference between the highest and the lowest Earning from trade(constant 2005 US) of Guatemala?
Provide a succinct answer. 2.10e+09. What is the difference between the highest and the lowest Earning from trade(constant 2005 US) of Nepal?
Offer a very short reply. 4.15e+08. 